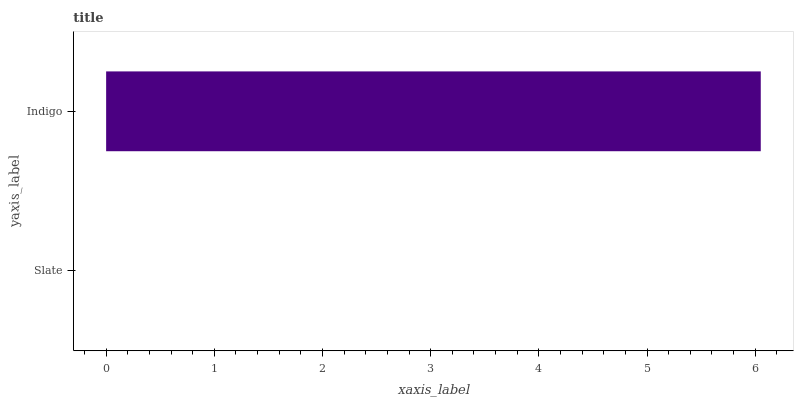Is Slate the minimum?
Answer yes or no. Yes. Is Indigo the maximum?
Answer yes or no. Yes. Is Indigo the minimum?
Answer yes or no. No. Is Indigo greater than Slate?
Answer yes or no. Yes. Is Slate less than Indigo?
Answer yes or no. Yes. Is Slate greater than Indigo?
Answer yes or no. No. Is Indigo less than Slate?
Answer yes or no. No. Is Indigo the high median?
Answer yes or no. Yes. Is Slate the low median?
Answer yes or no. Yes. Is Slate the high median?
Answer yes or no. No. Is Indigo the low median?
Answer yes or no. No. 